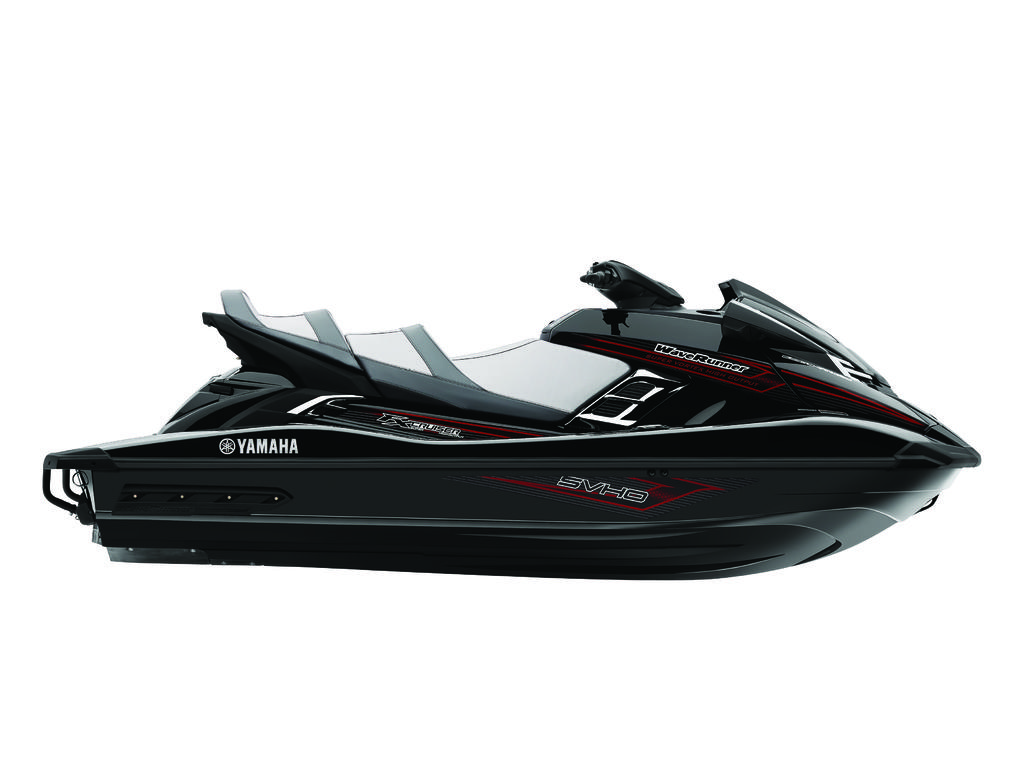What type of vehicle is in the image? There is a black motor jet ski in the image. Can you describe any specific features of the jet ski? There is some text visible on the jet ski. What type of bird can be seen sitting on the whip in the image? There is no bird or whip present in the image; it features a black motor jet ski with visible text. 